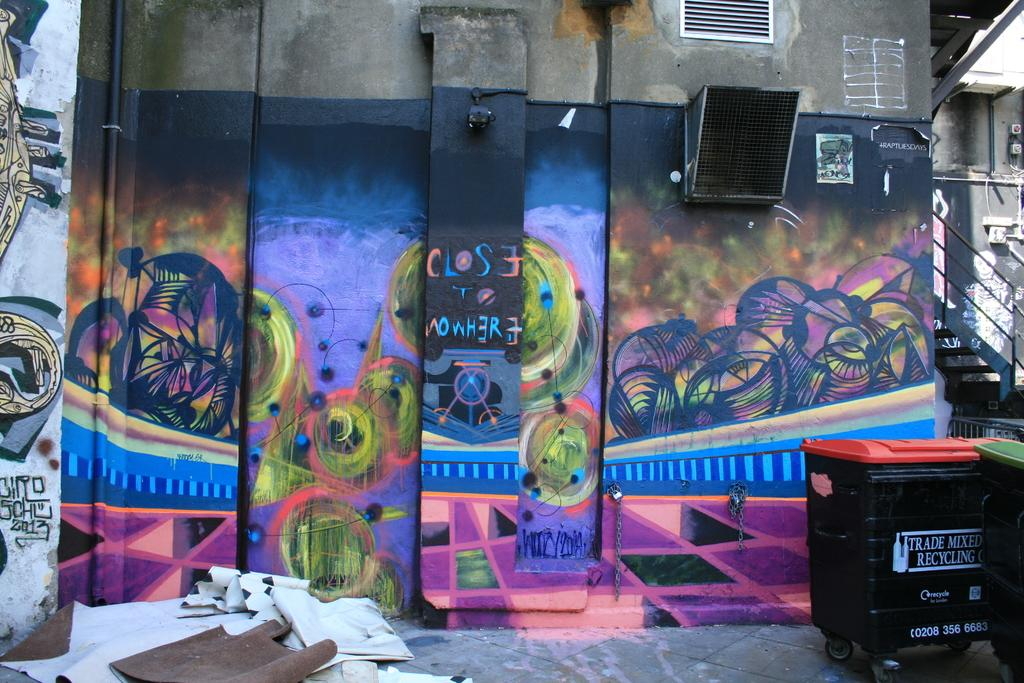<image>
Create a compact narrative representing the image presented. A trade mixed recycling bin sits behind a shop that has been covered in mostly purple graffiti. 